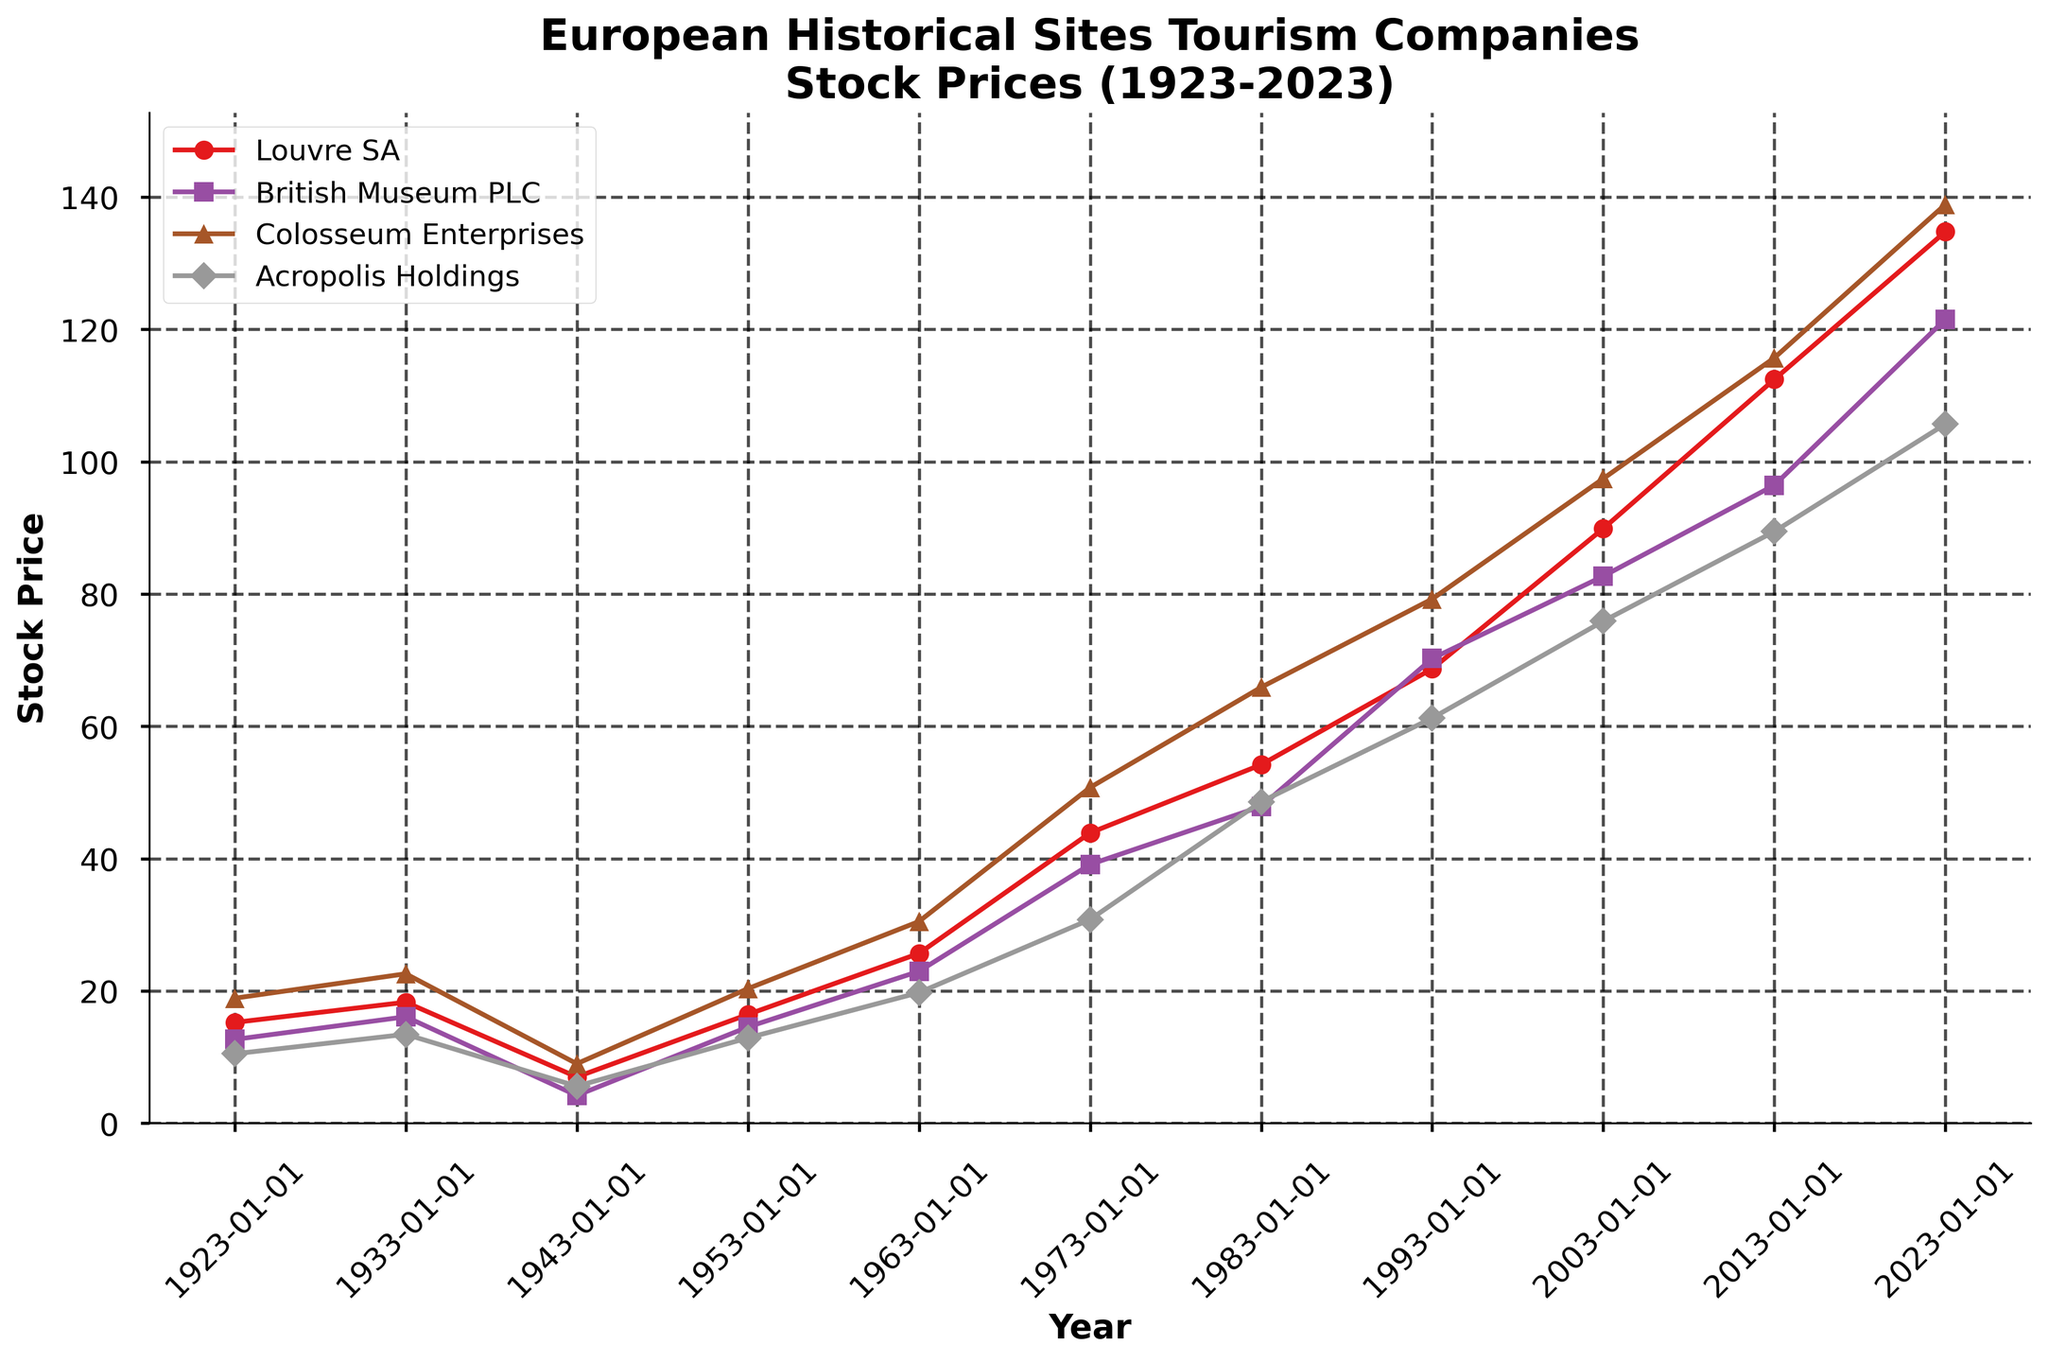what is the title of the plot? The title is located at the top of the plot in a larger font size. It provides a concise description of what the plot represents.
Answer: European Historical Sites Tourism Companies Stock Prices (1923-2023) how many companies' stock prices are shown in the plot? The plot has a unique line for each company, differentiated by colors and markers in the legend. There are four distinct companies listed.
Answer: four which company had the highest stock price in 2023? By checking the endpoints of the lines on the plot for the year 2023 and comparing their heights, you see that Colosseum Enterprises has the endpoint at the highest stock price.
Answer: Colosseum Enterprises between 1933 and 1943, which company's stock price showed the greatest decline? Observe the slopes of each company's line between these two points. Louvre SA, British Museum PLC, Colosseum Enterprises, and Acropolis Holdings all show a drop, but the steepest decline is seen in the Louvre SA stock price.
Answer: Louvre SA which company had the most consistent stock price increase over the century? Examine the overall trends in the lines on the plot, focusing on how smooth and consistent the increases are over time. Acropolis Holdings possibly has the smoothest upward trajectory without major fluctuations.
Answer: Acropolis Holdings what was the stock price difference between Louvre SA and British Museum PLC in 1983? Locate the points on the plot for 1983 for each company. Louvre SA was at 54.20 and British Museum PLC was at 47.89. Subtracting these gives 54.20 - 47.89.
Answer: 6.31 during which decade did Colosseum Enterprises have the greatest stock price increase? Evaluate the slopes in different decades by noting the points' positions for Colosseum Enterprises. The steepest rise is likely in the 1973-1983 period.
Answer: 1973-1983 what is the average stock price of Acropolis Holdings in 1923 and 2023? Identify the prices for Acropolis Holdings for these years. They are 10.50 in 1923 and 105.70 in 2023. The average would be calculated as (10.50 + 105.70)/2.
Answer: 58.10 